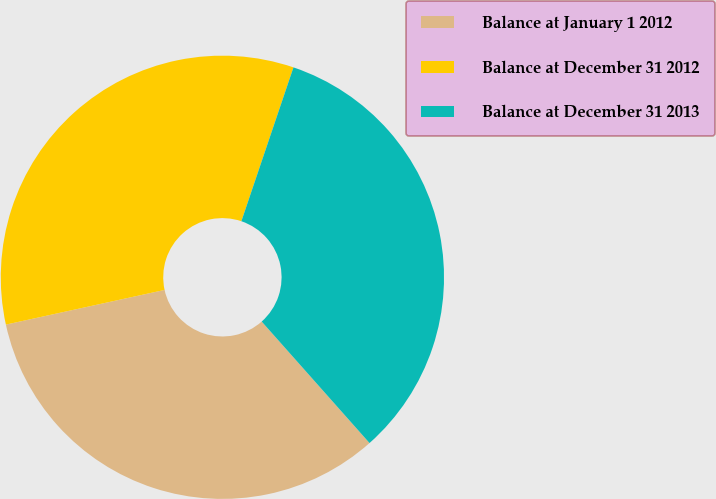Convert chart. <chart><loc_0><loc_0><loc_500><loc_500><pie_chart><fcel>Balance at January 1 2012<fcel>Balance at December 31 2012<fcel>Balance at December 31 2013<nl><fcel>33.13%<fcel>33.62%<fcel>33.25%<nl></chart> 